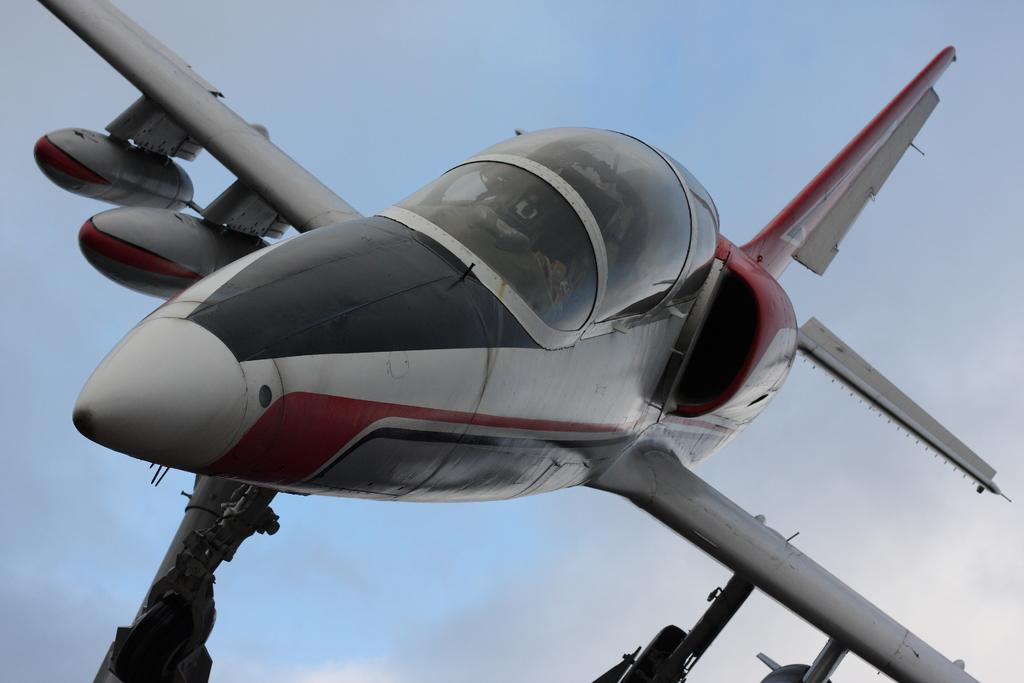What is the main subject of the image? The main subject of the image is an airplane. What can be seen in the background of the image? The sky is visible in the background of the image. How many bears are balancing on a stick in the image? There are no bears or sticks present in the image; it features an airplane and the sky. 